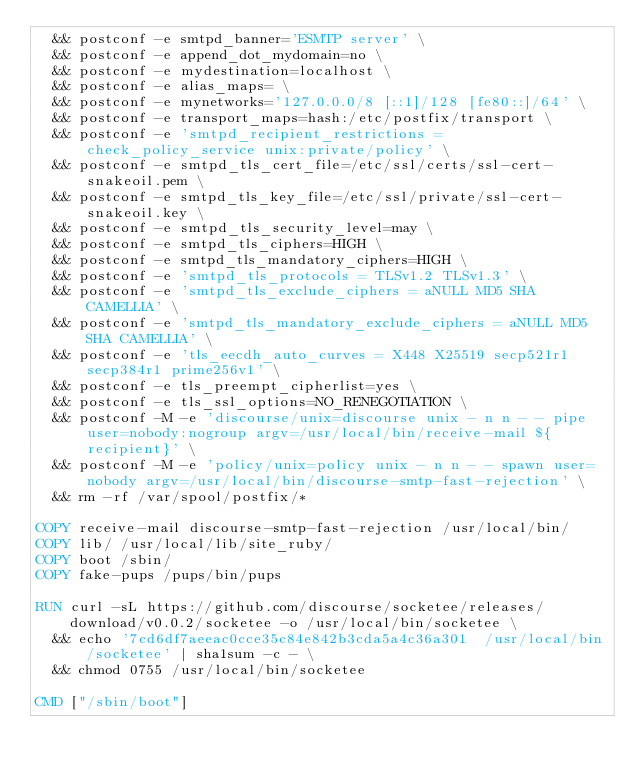<code> <loc_0><loc_0><loc_500><loc_500><_Dockerfile_>	&& postconf -e smtpd_banner='ESMTP server' \
	&& postconf -e append_dot_mydomain=no \
	&& postconf -e mydestination=localhost \
	&& postconf -e alias_maps= \
	&& postconf -e mynetworks='127.0.0.0/8 [::1]/128 [fe80::]/64' \
	&& postconf -e transport_maps=hash:/etc/postfix/transport \
	&& postconf -e 'smtpd_recipient_restrictions = check_policy_service unix:private/policy' \
	&& postconf -e smtpd_tls_cert_file=/etc/ssl/certs/ssl-cert-snakeoil.pem \
	&& postconf -e smtpd_tls_key_file=/etc/ssl/private/ssl-cert-snakeoil.key \
	&& postconf -e smtpd_tls_security_level=may \
	&& postconf -e smtpd_tls_ciphers=HIGH \
	&& postconf -e smtpd_tls_mandatory_ciphers=HIGH \
	&& postconf -e 'smtpd_tls_protocols = TLSv1.2 TLSv1.3' \
	&& postconf -e 'smtpd_tls_exclude_ciphers = aNULL MD5 SHA CAMELLIA' \
	&& postconf -e 'smtpd_tls_mandatory_exclude_ciphers = aNULL MD5 SHA CAMELLIA' \
	&& postconf -e 'tls_eecdh_auto_curves = X448 X25519 secp521r1 secp384r1 prime256v1' \
	&& postconf -e tls_preempt_cipherlist=yes \
	&& postconf -e tls_ssl_options=NO_RENEGOTIATION \
	&& postconf -M -e 'discourse/unix=discourse unix - n n - - pipe user=nobody:nogroup argv=/usr/local/bin/receive-mail ${recipient}' \
	&& postconf -M -e 'policy/unix=policy unix - n n - - spawn user=nobody argv=/usr/local/bin/discourse-smtp-fast-rejection' \
	&& rm -rf /var/spool/postfix/*

COPY receive-mail discourse-smtp-fast-rejection /usr/local/bin/
COPY lib/ /usr/local/lib/site_ruby/
COPY boot /sbin/
COPY fake-pups /pups/bin/pups

RUN curl -sL https://github.com/discourse/socketee/releases/download/v0.0.2/socketee -o /usr/local/bin/socketee \
	&& echo '7cd6df7aeeac0cce35c84e842b3cda5a4c36a301  /usr/local/bin/socketee' | sha1sum -c - \
	&& chmod 0755 /usr/local/bin/socketee

CMD ["/sbin/boot"]
</code> 